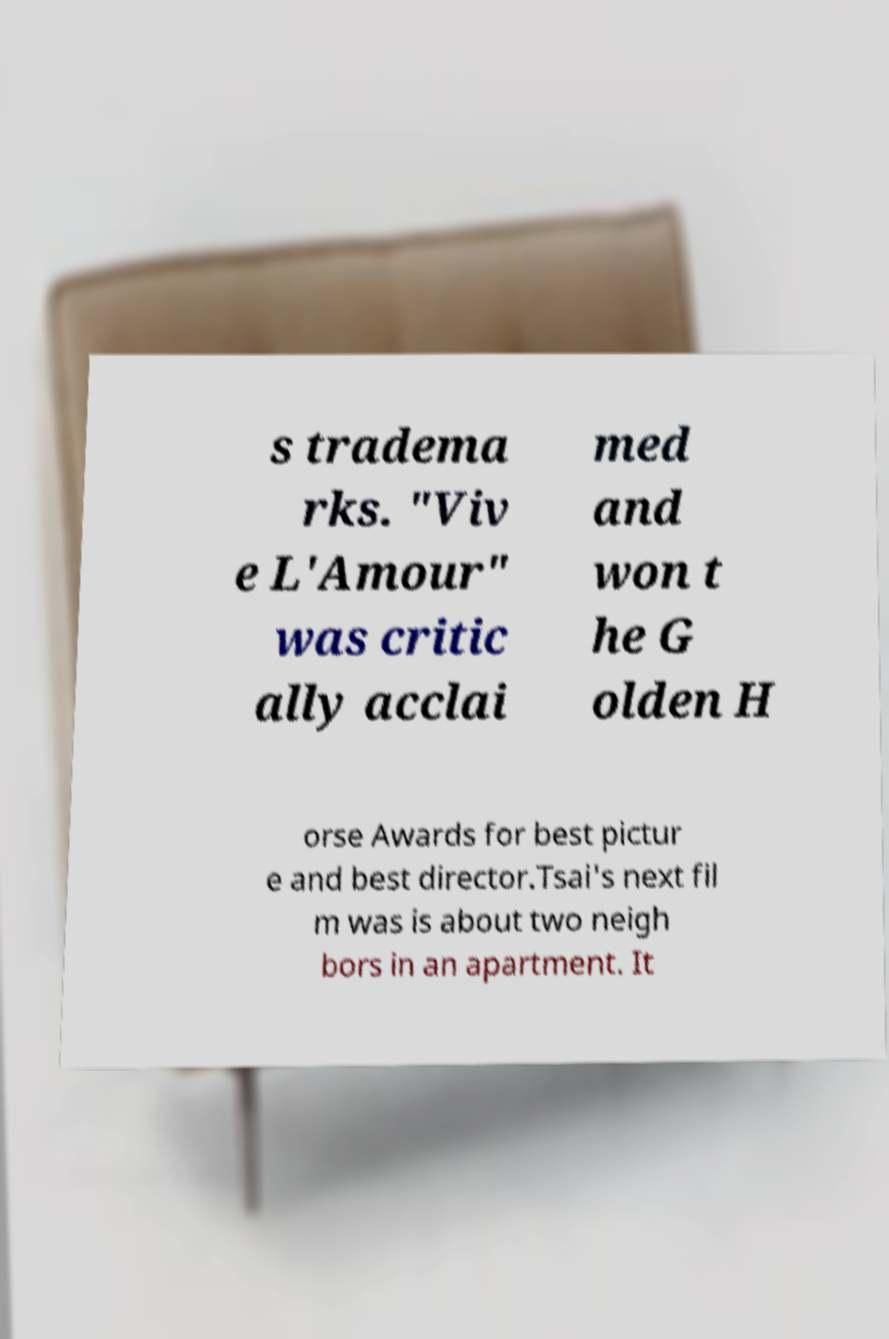Can you accurately transcribe the text from the provided image for me? s tradema rks. "Viv e L'Amour" was critic ally acclai med and won t he G olden H orse Awards for best pictur e and best director.Tsai's next fil m was is about two neigh bors in an apartment. It 